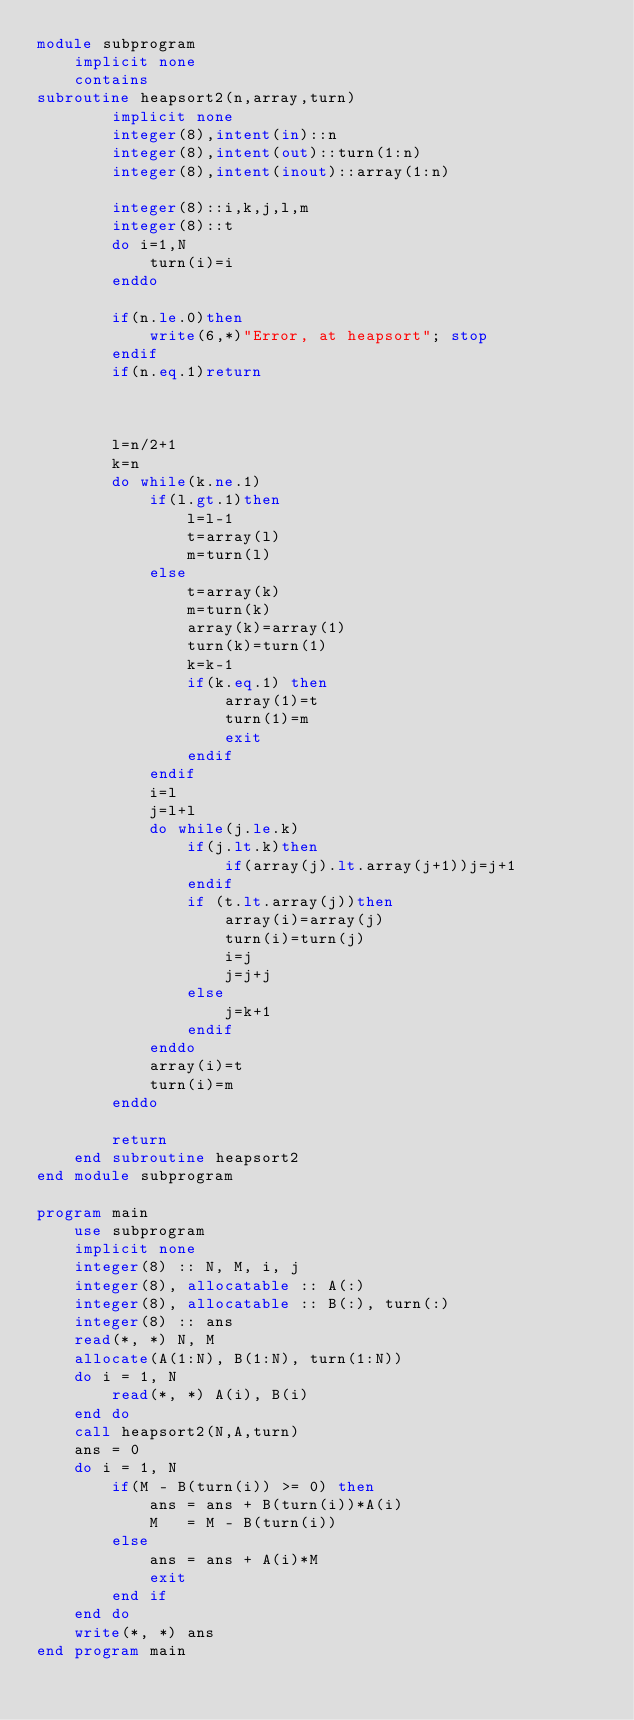Convert code to text. <code><loc_0><loc_0><loc_500><loc_500><_FORTRAN_>module subprogram
	implicit none
	contains
subroutine heapsort2(n,array,turn)
		implicit none
		integer(8),intent(in)::n
		integer(8),intent(out)::turn(1:n)
		integer(8),intent(inout)::array(1:n)
  
		integer(8)::i,k,j,l,m
		integer(8)::t
		do i=1,N
			turn(i)=i
		enddo  
		
		if(n.le.0)then
			write(6,*)"Error, at heapsort"; stop
		endif
		if(n.eq.1)return
 

 
		l=n/2+1
		k=n
		do while(k.ne.1)
			if(l.gt.1)then
				l=l-1
				t=array(l)
				m=turn(l)
			else
				t=array(k)
				m=turn(k)
				array(k)=array(1)
				turn(k)=turn(1)
				k=k-1
				if(k.eq.1) then
					array(1)=t
					turn(1)=m
					exit
				endif
			endif
			i=l
			j=l+l
			do while(j.le.k)
				if(j.lt.k)then
					if(array(j).lt.array(j+1))j=j+1
				endif
				if (t.lt.array(j))then
					array(i)=array(j)
					turn(i)=turn(j)
					i=j
					j=j+j
				else
					j=k+1
				endif
			enddo
			array(i)=t
			turn(i)=m
		enddo
 
		return
	end subroutine heapsort2
end module subprogram	

program main
	use subprogram
	implicit none
	integer(8) :: N, M, i, j
	integer(8), allocatable :: A(:)
	integer(8), allocatable :: B(:), turn(:)
	integer(8) :: ans
	read(*, *) N, M
	allocate(A(1:N), B(1:N), turn(1:N))
	do i = 1, N
		read(*, *) A(i), B(i)
	end do
	call heapsort2(N,A,turn)
	ans = 0
	do i = 1, N
		if(M - B(turn(i)) >= 0) then
			ans = ans + B(turn(i))*A(i)
			M   = M - B(turn(i))
		else
			ans = ans + A(i)*M
			exit
		end if
	end do
	write(*, *) ans
end program main</code> 